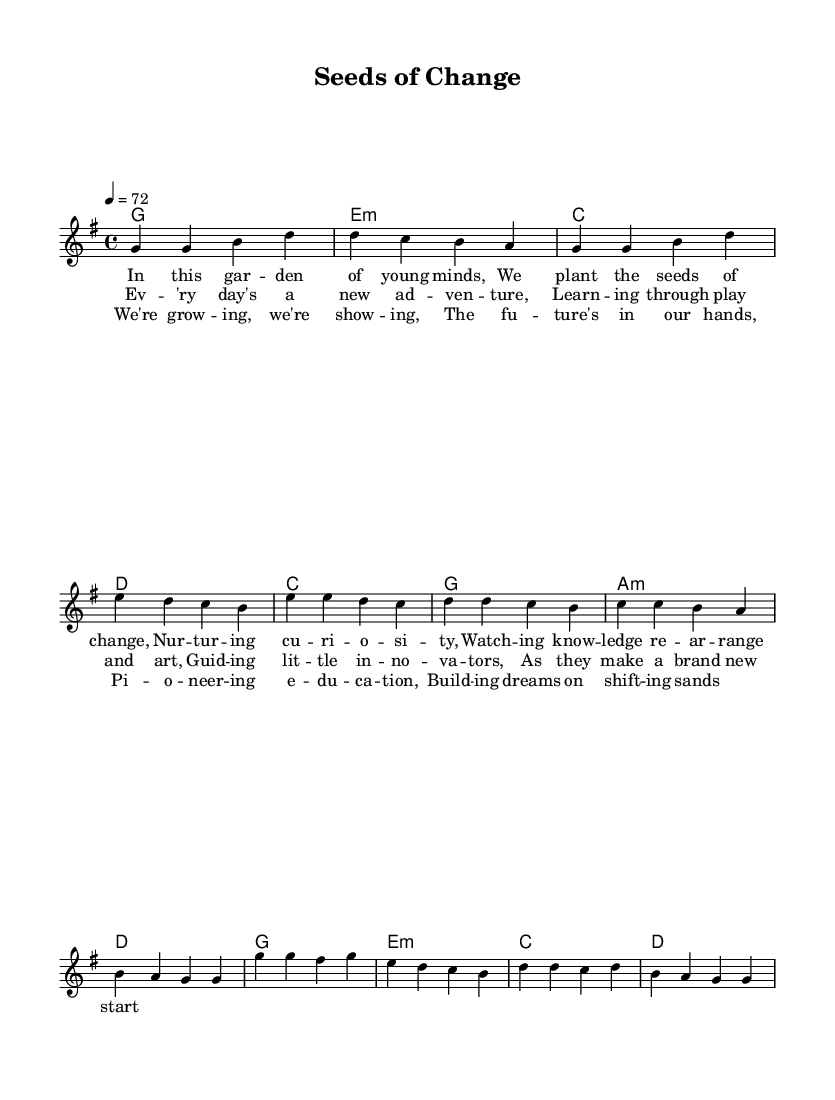What is the key signature of this music? The key signature is indicated by the presence of one sharp. This sharp is F#, which is typical for the key of G major. Therefore, the key signature reflects this.
Answer: G major What is the time signature of this music? The time signature is located at the start of the music notation and is expressed as 4/4. This indicates that there are four beats in each measure and the quarter note gets one beat.
Answer: 4/4 What is the tempo marking for this piece? The tempo marking indicates the speed of the music, noted at the beginning as "4 = 72," which means there are 72 beats per minute. This helps performers understand how quickly to play the piece.
Answer: 72 How many measures are in the chorus section? By counting the number of measures in the section dedicated to the chorus, we notice there are four measures. Each measure is separated by a vertical bar line, making it simple to see the structure.
Answer: 4 What emotion is conveyed in the lyrics of the verse? The lyrics in the verse express a nurturing and hopeful sentiment, focusing on planting "seeds of change" and cultivating curiosity in young minds. Analyzing keywords from the lyrics suggests a positive outlook toward education.
Answer: Hopeful What musical elements support the theme of educational innovation in the harmony? The harmonies used in this piece feature common pop chord progressions, creating an uplifting and encouraging sound which complements the theme of educational innovation. Chords such as G, E minor, C, and D are prevalent, building a supportive atmosphere for the lyrics.
Answer: Uplifting 